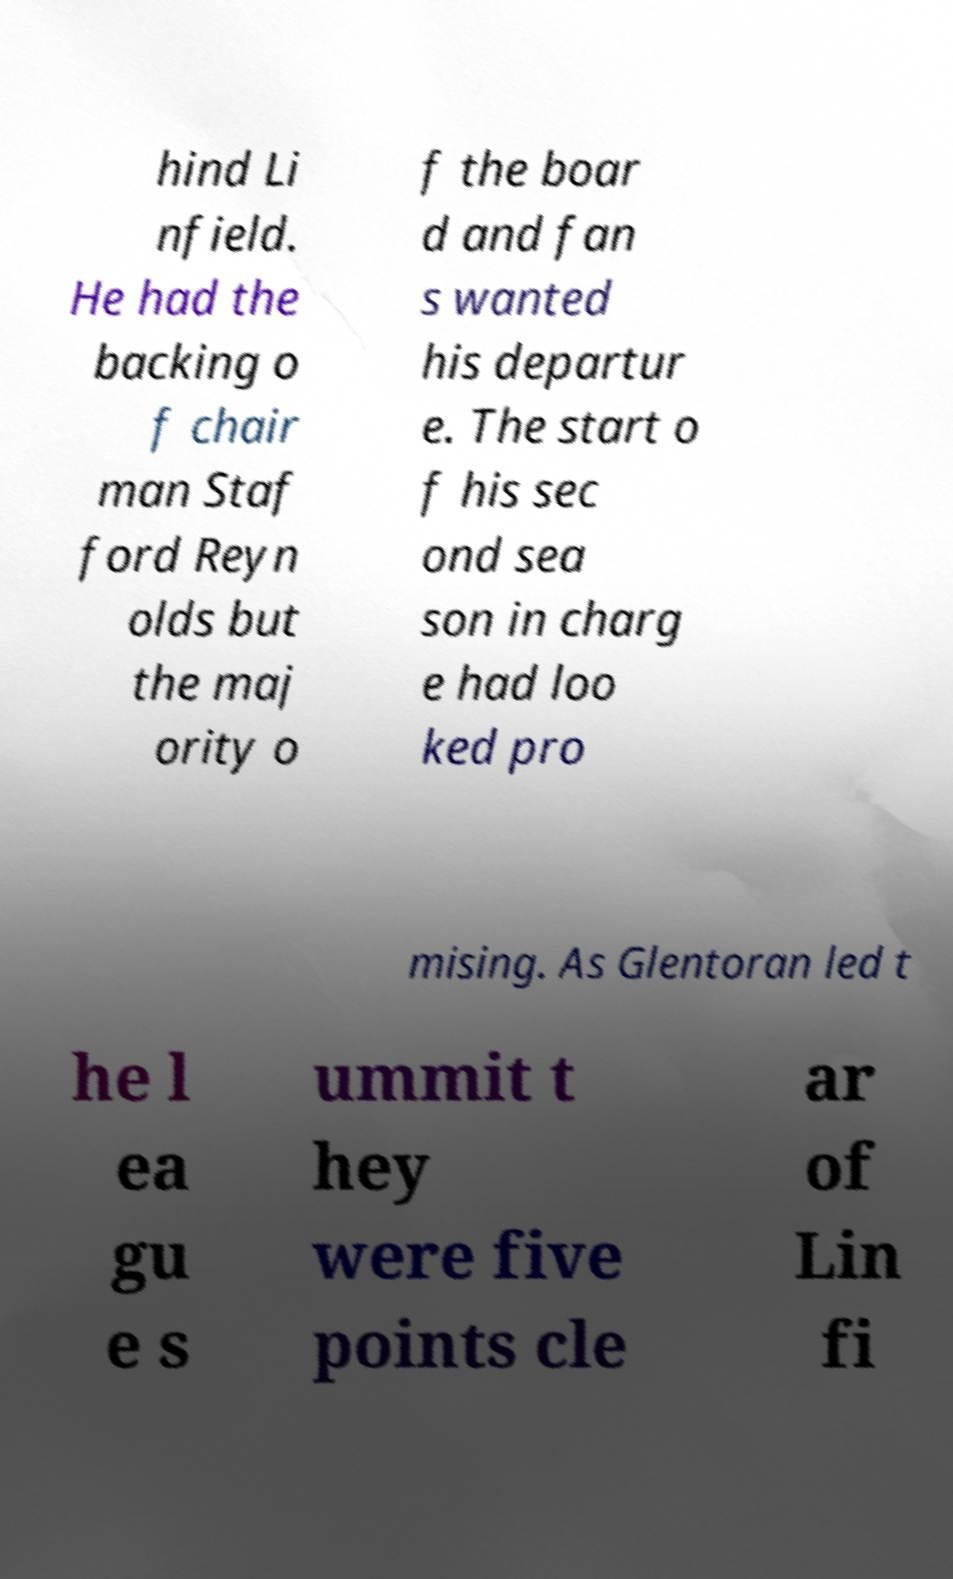Can you accurately transcribe the text from the provided image for me? hind Li nfield. He had the backing o f chair man Staf ford Reyn olds but the maj ority o f the boar d and fan s wanted his departur e. The start o f his sec ond sea son in charg e had loo ked pro mising. As Glentoran led t he l ea gu e s ummit t hey were five points cle ar of Lin fi 